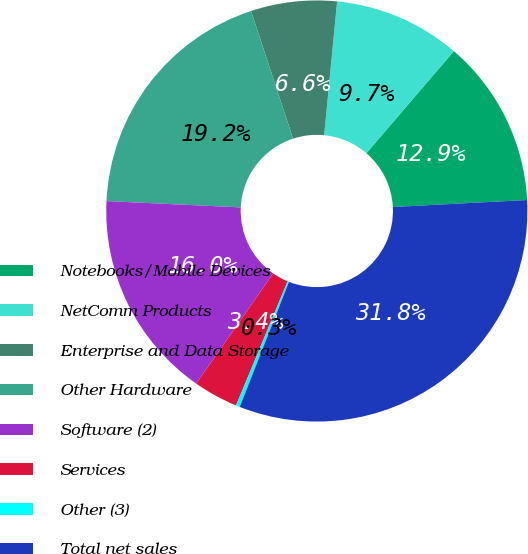<chart> <loc_0><loc_0><loc_500><loc_500><pie_chart><fcel>Notebooks/Mobile Devices<fcel>NetComm Products<fcel>Enterprise and Data Storage<fcel>Other Hardware<fcel>Software (2)<fcel>Services<fcel>Other (3)<fcel>Total net sales<nl><fcel>12.89%<fcel>9.74%<fcel>6.59%<fcel>19.19%<fcel>16.04%<fcel>3.44%<fcel>0.3%<fcel>31.79%<nl></chart> 